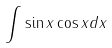Convert formula to latex. <formula><loc_0><loc_0><loc_500><loc_500>\int \sin x \cos x d x</formula> 